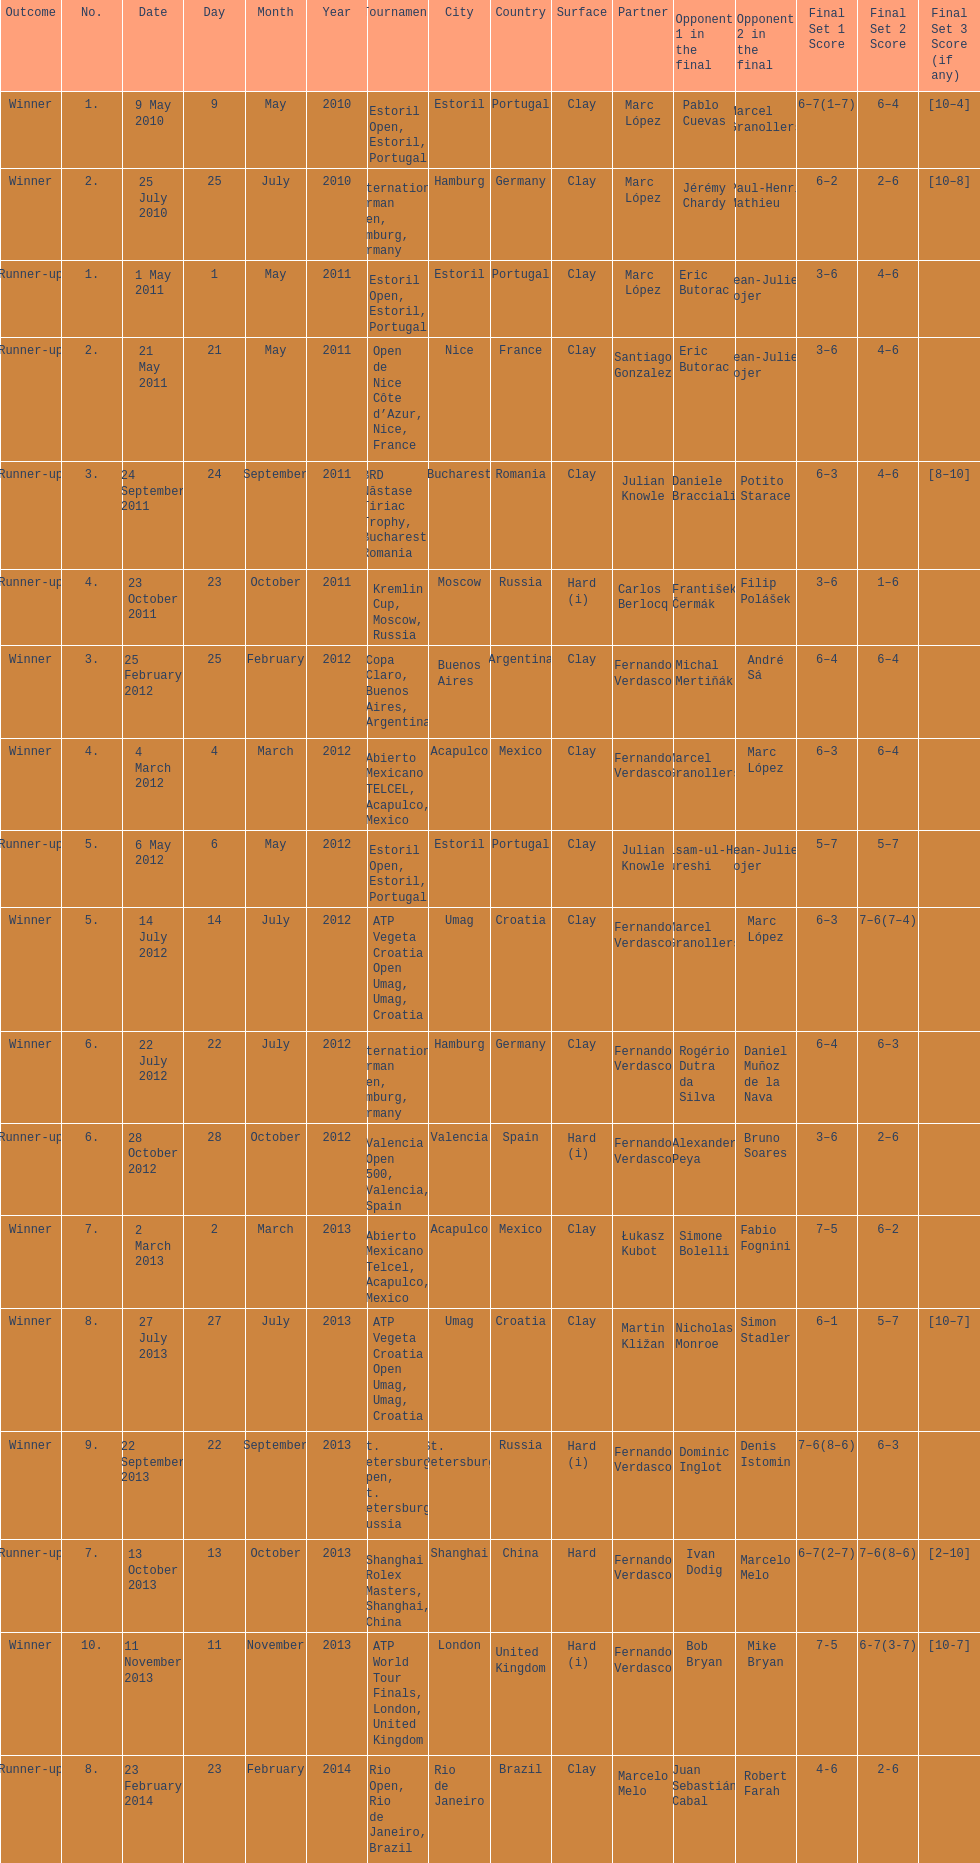How many winners are there? 10. 